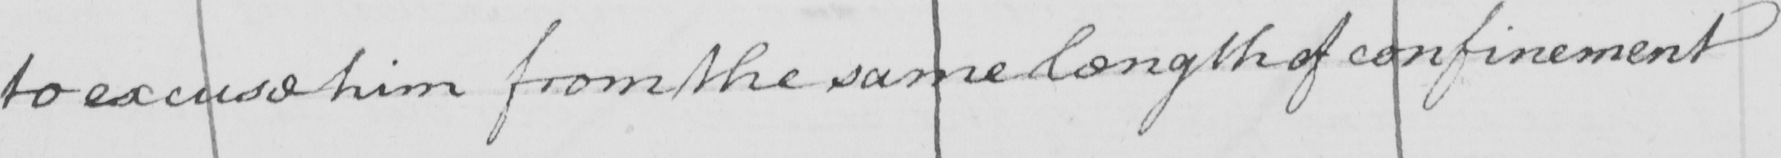What text is written in this handwritten line? to excuse him from the same length of confinement 